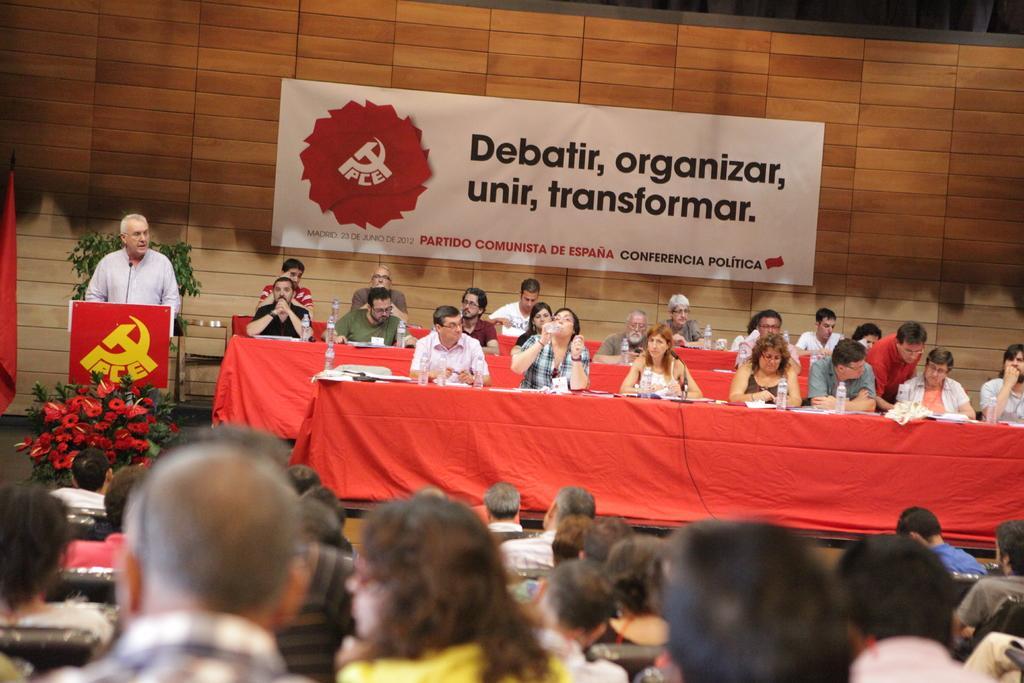Please provide a concise description of this image. In this picture there are two persons sitting and there is a table in front of them which has few objects on it and there is a person standing in the left corner and there is a mic and few audience in front of him. 